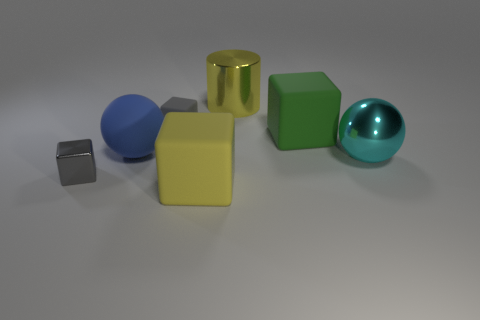Subtract all red spheres. Subtract all brown blocks. How many spheres are left? 2 Subtract all cubes. How many objects are left? 3 Subtract all cyan rubber cubes. Subtract all big green blocks. How many objects are left? 6 Add 2 large blue matte balls. How many large blue matte balls are left? 3 Add 1 green rubber cubes. How many green rubber cubes exist? 2 Subtract 1 yellow cylinders. How many objects are left? 6 